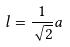<formula> <loc_0><loc_0><loc_500><loc_500>l = \frac { 1 } { \sqrt { 2 } } a</formula> 